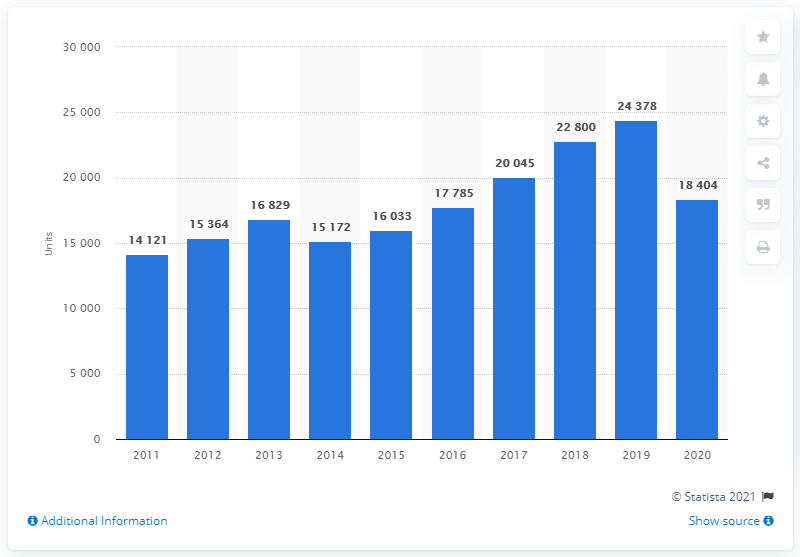Draw attention to some important aspects in this diagram. In 2011, a total of 14,121 Hyundai cars were registered in Poland. In 2020, a total of 18,404 Hyundai cars were registered in Poland. 